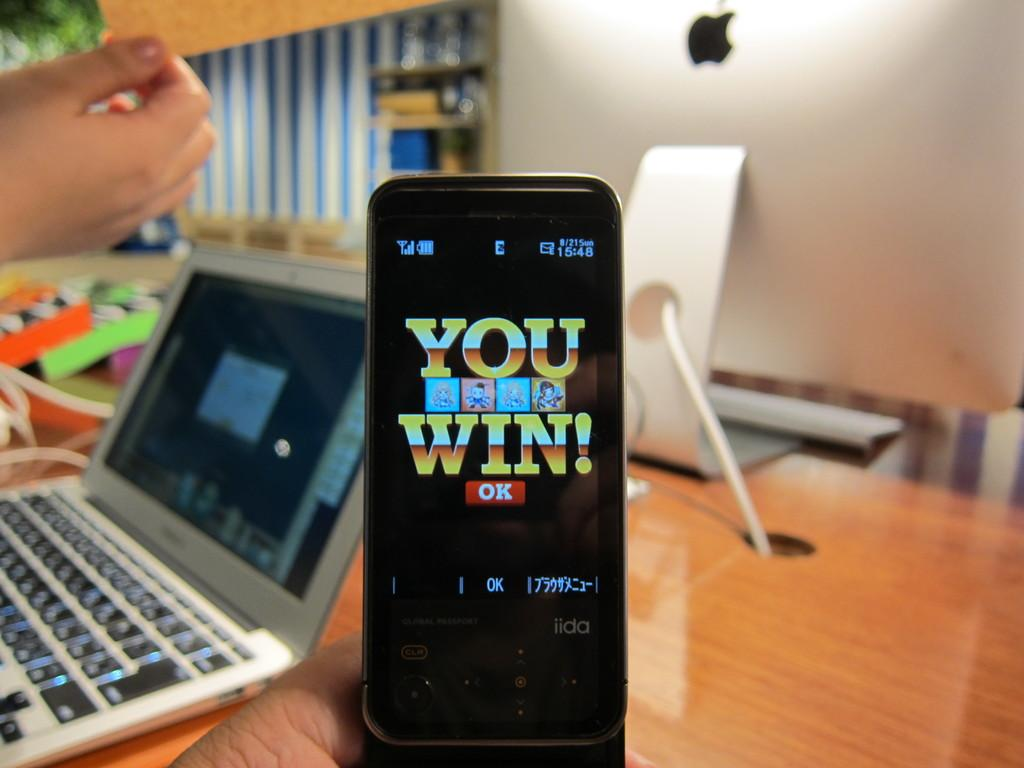<image>
Write a terse but informative summary of the picture. A smartphone displays the message You Win on it. 